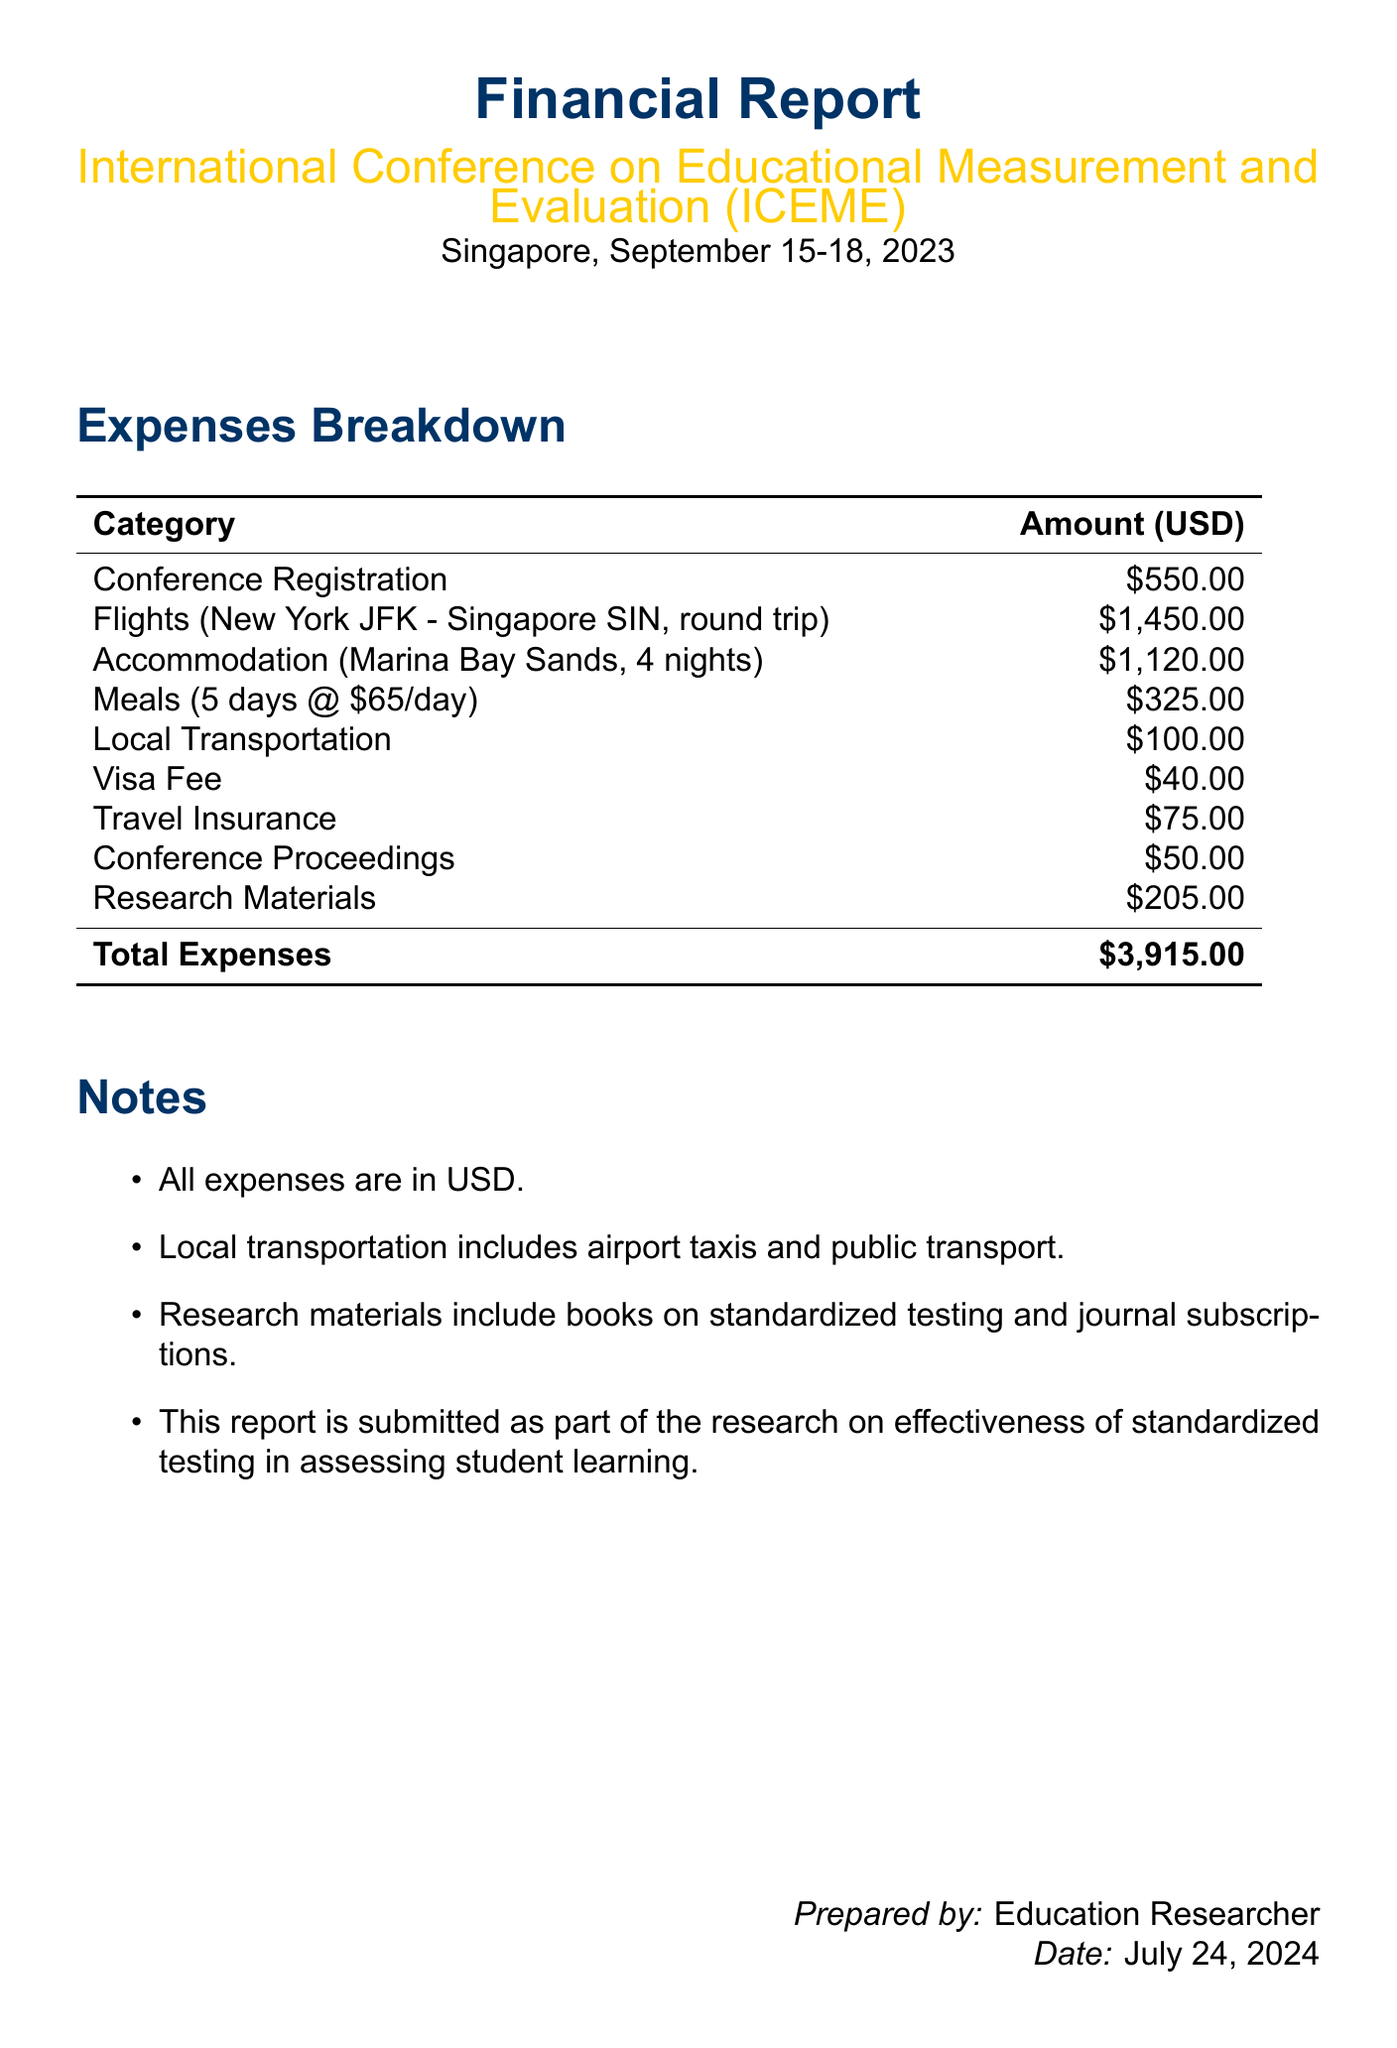What is the total expense? The total expense is calculated by summing all individual expense categories listed in the report.
Answer: $3,915.00 What is the registration fee for the conference? The registration fee is specified in the conference details section of the document.
Answer: $550.00 How many nights was accommodation booked for? The number of nights of accommodation is stated in the accommodation section of the report.
Answer: 4 What is the cost of flights? The cost of flights is detailed in the travel expenses section of the document.
Answer: $1,450.00 What is the total cost for meals? The total meal cost is provided in the meal expenses section, calculated based on the per diem and number of days.
Answer: $325.00 What is included in local transportation costs? Local transportation costs include transportation methods utilized during the trip, as outlined in the document.
Answer: Taxi and public transport What city hosted the conference? The location of the conference is clearly mentioned in the document's header.
Answer: Singapore Which hotel was used for accommodation? The hotel name is specified in the accommodation section of the report.
Answer: Marina Bay Sands What are the research materials related to? The research materials category details the focus of the materials purchased for the conference.
Answer: Standardized testing 